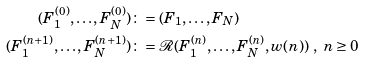Convert formula to latex. <formula><loc_0><loc_0><loc_500><loc_500>( F ^ { ( 0 ) } _ { 1 } , \dots , F ^ { ( 0 ) } _ { N } ) & \colon = ( F _ { 1 } , \dots , F _ { N } ) \\ ( F ^ { ( n + 1 ) } _ { 1 } , \dots , F ^ { ( n + 1 ) } _ { N } ) & \colon = \mathcal { R } ( F ^ { ( n ) } _ { 1 } , \dots , F ^ { ( n ) } _ { N } , w ( n ) ) \ , \ n \geq 0 \\</formula> 